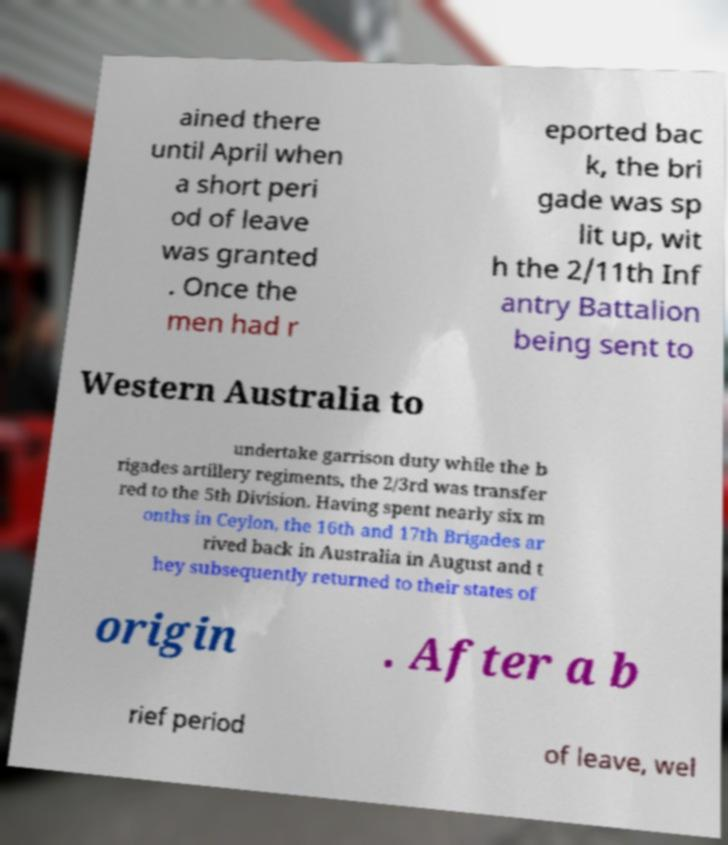Can you read and provide the text displayed in the image?This photo seems to have some interesting text. Can you extract and type it out for me? ained there until April when a short peri od of leave was granted . Once the men had r eported bac k, the bri gade was sp lit up, wit h the 2/11th Inf antry Battalion being sent to Western Australia to undertake garrison duty while the b rigades artillery regiments, the 2/3rd was transfer red to the 5th Division. Having spent nearly six m onths in Ceylon, the 16th and 17th Brigades ar rived back in Australia in August and t hey subsequently returned to their states of origin . After a b rief period of leave, wel 